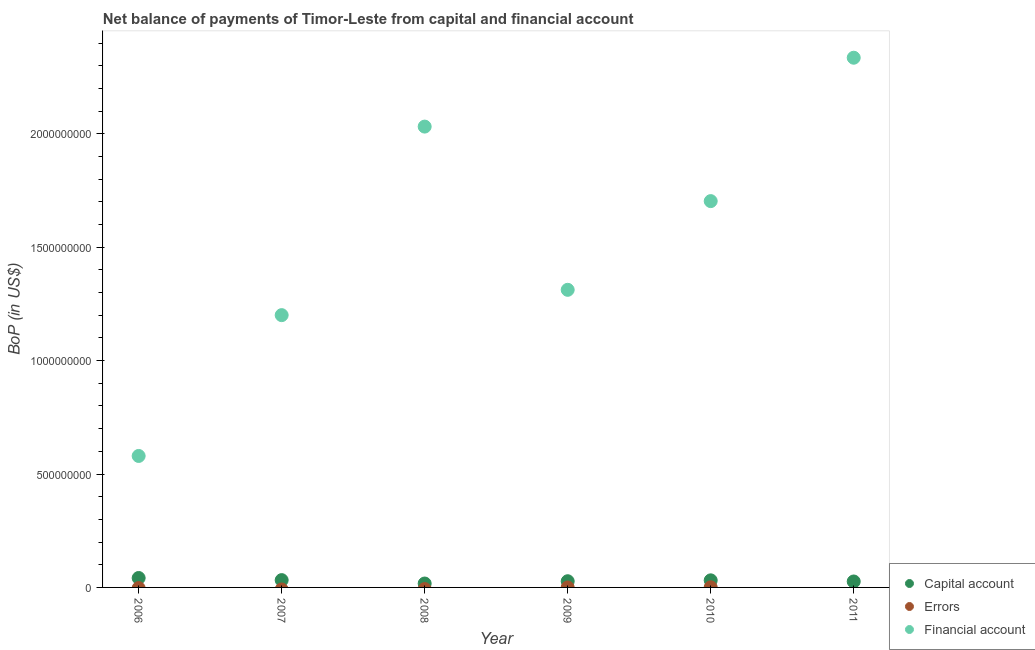How many different coloured dotlines are there?
Offer a terse response. 3. Is the number of dotlines equal to the number of legend labels?
Your answer should be compact. No. What is the amount of financial account in 2011?
Provide a short and direct response. 2.34e+09. Across all years, what is the maximum amount of financial account?
Make the answer very short. 2.34e+09. Across all years, what is the minimum amount of net capital account?
Your answer should be compact. 1.72e+07. What is the total amount of financial account in the graph?
Your answer should be very brief. 9.16e+09. What is the difference between the amount of net capital account in 2007 and that in 2009?
Keep it short and to the point. 4.88e+06. What is the difference between the amount of errors in 2009 and the amount of financial account in 2008?
Make the answer very short. -2.03e+09. What is the average amount of financial account per year?
Make the answer very short. 1.53e+09. In the year 2010, what is the difference between the amount of errors and amount of financial account?
Provide a short and direct response. -1.70e+09. What is the ratio of the amount of financial account in 2008 to that in 2009?
Provide a succinct answer. 1.55. Is the amount of financial account in 2007 less than that in 2008?
Offer a very short reply. Yes. Is the difference between the amount of net capital account in 2010 and 2011 greater than the difference between the amount of financial account in 2010 and 2011?
Keep it short and to the point. Yes. What is the difference between the highest and the second highest amount of net capital account?
Provide a short and direct response. 9.38e+06. What is the difference between the highest and the lowest amount of financial account?
Your answer should be very brief. 1.76e+09. In how many years, is the amount of net capital account greater than the average amount of net capital account taken over all years?
Make the answer very short. 3. Is the sum of the amount of financial account in 2007 and 2011 greater than the maximum amount of net capital account across all years?
Provide a succinct answer. Yes. Is the amount of net capital account strictly less than the amount of financial account over the years?
Offer a terse response. Yes. How many years are there in the graph?
Keep it short and to the point. 6. Does the graph contain any zero values?
Ensure brevity in your answer.  Yes. How many legend labels are there?
Your answer should be compact. 3. What is the title of the graph?
Provide a short and direct response. Net balance of payments of Timor-Leste from capital and financial account. What is the label or title of the X-axis?
Your response must be concise. Year. What is the label or title of the Y-axis?
Keep it short and to the point. BoP (in US$). What is the BoP (in US$) of Capital account in 2006?
Provide a succinct answer. 4.16e+07. What is the BoP (in US$) of Financial account in 2006?
Keep it short and to the point. 5.80e+08. What is the BoP (in US$) in Capital account in 2007?
Give a very brief answer. 3.22e+07. What is the BoP (in US$) in Errors in 2007?
Your answer should be compact. 0. What is the BoP (in US$) in Financial account in 2007?
Your answer should be very brief. 1.20e+09. What is the BoP (in US$) of Capital account in 2008?
Offer a very short reply. 1.72e+07. What is the BoP (in US$) of Financial account in 2008?
Give a very brief answer. 2.03e+09. What is the BoP (in US$) of Capital account in 2009?
Make the answer very short. 2.73e+07. What is the BoP (in US$) of Errors in 2009?
Your answer should be very brief. 0. What is the BoP (in US$) of Financial account in 2009?
Give a very brief answer. 1.31e+09. What is the BoP (in US$) of Capital account in 2010?
Make the answer very short. 3.13e+07. What is the BoP (in US$) of Errors in 2010?
Your answer should be compact. 5.13e+05. What is the BoP (in US$) in Financial account in 2010?
Make the answer very short. 1.70e+09. What is the BoP (in US$) of Capital account in 2011?
Give a very brief answer. 2.62e+07. What is the BoP (in US$) in Errors in 2011?
Make the answer very short. 0. What is the BoP (in US$) of Financial account in 2011?
Offer a very short reply. 2.34e+09. Across all years, what is the maximum BoP (in US$) of Capital account?
Provide a succinct answer. 4.16e+07. Across all years, what is the maximum BoP (in US$) of Errors?
Ensure brevity in your answer.  5.13e+05. Across all years, what is the maximum BoP (in US$) of Financial account?
Provide a succinct answer. 2.34e+09. Across all years, what is the minimum BoP (in US$) in Capital account?
Your answer should be very brief. 1.72e+07. Across all years, what is the minimum BoP (in US$) in Errors?
Provide a short and direct response. 0. Across all years, what is the minimum BoP (in US$) of Financial account?
Your response must be concise. 5.80e+08. What is the total BoP (in US$) of Capital account in the graph?
Your answer should be compact. 1.76e+08. What is the total BoP (in US$) of Errors in the graph?
Your answer should be compact. 5.13e+05. What is the total BoP (in US$) of Financial account in the graph?
Provide a short and direct response. 9.16e+09. What is the difference between the BoP (in US$) of Capital account in 2006 and that in 2007?
Your answer should be very brief. 9.38e+06. What is the difference between the BoP (in US$) in Financial account in 2006 and that in 2007?
Your answer should be compact. -6.21e+08. What is the difference between the BoP (in US$) in Capital account in 2006 and that in 2008?
Make the answer very short. 2.44e+07. What is the difference between the BoP (in US$) of Financial account in 2006 and that in 2008?
Offer a very short reply. -1.45e+09. What is the difference between the BoP (in US$) in Capital account in 2006 and that in 2009?
Offer a terse response. 1.43e+07. What is the difference between the BoP (in US$) in Financial account in 2006 and that in 2009?
Make the answer very short. -7.33e+08. What is the difference between the BoP (in US$) of Capital account in 2006 and that in 2010?
Give a very brief answer. 1.03e+07. What is the difference between the BoP (in US$) of Financial account in 2006 and that in 2010?
Keep it short and to the point. -1.12e+09. What is the difference between the BoP (in US$) in Capital account in 2006 and that in 2011?
Offer a terse response. 1.54e+07. What is the difference between the BoP (in US$) of Financial account in 2006 and that in 2011?
Your answer should be very brief. -1.76e+09. What is the difference between the BoP (in US$) in Capital account in 2007 and that in 2008?
Your answer should be compact. 1.50e+07. What is the difference between the BoP (in US$) of Financial account in 2007 and that in 2008?
Make the answer very short. -8.31e+08. What is the difference between the BoP (in US$) of Capital account in 2007 and that in 2009?
Ensure brevity in your answer.  4.88e+06. What is the difference between the BoP (in US$) in Financial account in 2007 and that in 2009?
Your answer should be compact. -1.12e+08. What is the difference between the BoP (in US$) of Capital account in 2007 and that in 2010?
Make the answer very short. 9.62e+05. What is the difference between the BoP (in US$) in Financial account in 2007 and that in 2010?
Provide a succinct answer. -5.03e+08. What is the difference between the BoP (in US$) of Capital account in 2007 and that in 2011?
Offer a very short reply. 5.99e+06. What is the difference between the BoP (in US$) in Financial account in 2007 and that in 2011?
Provide a succinct answer. -1.13e+09. What is the difference between the BoP (in US$) of Capital account in 2008 and that in 2009?
Keep it short and to the point. -1.01e+07. What is the difference between the BoP (in US$) in Financial account in 2008 and that in 2009?
Make the answer very short. 7.20e+08. What is the difference between the BoP (in US$) in Capital account in 2008 and that in 2010?
Your answer should be compact. -1.40e+07. What is the difference between the BoP (in US$) in Financial account in 2008 and that in 2010?
Make the answer very short. 3.29e+08. What is the difference between the BoP (in US$) of Capital account in 2008 and that in 2011?
Ensure brevity in your answer.  -8.99e+06. What is the difference between the BoP (in US$) in Financial account in 2008 and that in 2011?
Provide a succinct answer. -3.04e+08. What is the difference between the BoP (in US$) of Capital account in 2009 and that in 2010?
Make the answer very short. -3.92e+06. What is the difference between the BoP (in US$) of Financial account in 2009 and that in 2010?
Your answer should be compact. -3.91e+08. What is the difference between the BoP (in US$) in Capital account in 2009 and that in 2011?
Make the answer very short. 1.11e+06. What is the difference between the BoP (in US$) in Financial account in 2009 and that in 2011?
Provide a short and direct response. -1.02e+09. What is the difference between the BoP (in US$) in Capital account in 2010 and that in 2011?
Your answer should be very brief. 5.03e+06. What is the difference between the BoP (in US$) of Financial account in 2010 and that in 2011?
Offer a terse response. -6.32e+08. What is the difference between the BoP (in US$) of Capital account in 2006 and the BoP (in US$) of Financial account in 2007?
Offer a terse response. -1.16e+09. What is the difference between the BoP (in US$) of Capital account in 2006 and the BoP (in US$) of Financial account in 2008?
Ensure brevity in your answer.  -1.99e+09. What is the difference between the BoP (in US$) in Capital account in 2006 and the BoP (in US$) in Financial account in 2009?
Make the answer very short. -1.27e+09. What is the difference between the BoP (in US$) in Capital account in 2006 and the BoP (in US$) in Errors in 2010?
Make the answer very short. 4.11e+07. What is the difference between the BoP (in US$) in Capital account in 2006 and the BoP (in US$) in Financial account in 2010?
Offer a very short reply. -1.66e+09. What is the difference between the BoP (in US$) in Capital account in 2006 and the BoP (in US$) in Financial account in 2011?
Make the answer very short. -2.29e+09. What is the difference between the BoP (in US$) in Capital account in 2007 and the BoP (in US$) in Financial account in 2008?
Offer a very short reply. -2.00e+09. What is the difference between the BoP (in US$) of Capital account in 2007 and the BoP (in US$) of Financial account in 2009?
Offer a very short reply. -1.28e+09. What is the difference between the BoP (in US$) of Capital account in 2007 and the BoP (in US$) of Errors in 2010?
Give a very brief answer. 3.17e+07. What is the difference between the BoP (in US$) of Capital account in 2007 and the BoP (in US$) of Financial account in 2010?
Provide a short and direct response. -1.67e+09. What is the difference between the BoP (in US$) of Capital account in 2007 and the BoP (in US$) of Financial account in 2011?
Ensure brevity in your answer.  -2.30e+09. What is the difference between the BoP (in US$) of Capital account in 2008 and the BoP (in US$) of Financial account in 2009?
Give a very brief answer. -1.29e+09. What is the difference between the BoP (in US$) of Capital account in 2008 and the BoP (in US$) of Errors in 2010?
Your answer should be compact. 1.67e+07. What is the difference between the BoP (in US$) in Capital account in 2008 and the BoP (in US$) in Financial account in 2010?
Your answer should be very brief. -1.69e+09. What is the difference between the BoP (in US$) of Capital account in 2008 and the BoP (in US$) of Financial account in 2011?
Make the answer very short. -2.32e+09. What is the difference between the BoP (in US$) in Capital account in 2009 and the BoP (in US$) in Errors in 2010?
Provide a short and direct response. 2.68e+07. What is the difference between the BoP (in US$) of Capital account in 2009 and the BoP (in US$) of Financial account in 2010?
Offer a very short reply. -1.68e+09. What is the difference between the BoP (in US$) of Capital account in 2009 and the BoP (in US$) of Financial account in 2011?
Your response must be concise. -2.31e+09. What is the difference between the BoP (in US$) of Capital account in 2010 and the BoP (in US$) of Financial account in 2011?
Provide a short and direct response. -2.30e+09. What is the difference between the BoP (in US$) of Errors in 2010 and the BoP (in US$) of Financial account in 2011?
Your answer should be compact. -2.33e+09. What is the average BoP (in US$) in Capital account per year?
Offer a very short reply. 2.93e+07. What is the average BoP (in US$) in Errors per year?
Your answer should be very brief. 8.55e+04. What is the average BoP (in US$) of Financial account per year?
Keep it short and to the point. 1.53e+09. In the year 2006, what is the difference between the BoP (in US$) in Capital account and BoP (in US$) in Financial account?
Ensure brevity in your answer.  -5.38e+08. In the year 2007, what is the difference between the BoP (in US$) of Capital account and BoP (in US$) of Financial account?
Make the answer very short. -1.17e+09. In the year 2008, what is the difference between the BoP (in US$) of Capital account and BoP (in US$) of Financial account?
Your answer should be very brief. -2.01e+09. In the year 2009, what is the difference between the BoP (in US$) of Capital account and BoP (in US$) of Financial account?
Provide a short and direct response. -1.28e+09. In the year 2010, what is the difference between the BoP (in US$) of Capital account and BoP (in US$) of Errors?
Your answer should be very brief. 3.07e+07. In the year 2010, what is the difference between the BoP (in US$) in Capital account and BoP (in US$) in Financial account?
Your response must be concise. -1.67e+09. In the year 2010, what is the difference between the BoP (in US$) in Errors and BoP (in US$) in Financial account?
Your answer should be very brief. -1.70e+09. In the year 2011, what is the difference between the BoP (in US$) of Capital account and BoP (in US$) of Financial account?
Your answer should be very brief. -2.31e+09. What is the ratio of the BoP (in US$) of Capital account in 2006 to that in 2007?
Provide a succinct answer. 1.29. What is the ratio of the BoP (in US$) in Financial account in 2006 to that in 2007?
Make the answer very short. 0.48. What is the ratio of the BoP (in US$) of Capital account in 2006 to that in 2008?
Give a very brief answer. 2.41. What is the ratio of the BoP (in US$) in Financial account in 2006 to that in 2008?
Offer a very short reply. 0.29. What is the ratio of the BoP (in US$) in Capital account in 2006 to that in 2009?
Offer a very short reply. 1.52. What is the ratio of the BoP (in US$) in Financial account in 2006 to that in 2009?
Offer a very short reply. 0.44. What is the ratio of the BoP (in US$) of Capital account in 2006 to that in 2010?
Offer a very short reply. 1.33. What is the ratio of the BoP (in US$) of Financial account in 2006 to that in 2010?
Your answer should be very brief. 0.34. What is the ratio of the BoP (in US$) of Capital account in 2006 to that in 2011?
Keep it short and to the point. 1.59. What is the ratio of the BoP (in US$) in Financial account in 2006 to that in 2011?
Provide a short and direct response. 0.25. What is the ratio of the BoP (in US$) of Capital account in 2007 to that in 2008?
Keep it short and to the point. 1.87. What is the ratio of the BoP (in US$) of Financial account in 2007 to that in 2008?
Make the answer very short. 0.59. What is the ratio of the BoP (in US$) of Capital account in 2007 to that in 2009?
Ensure brevity in your answer.  1.18. What is the ratio of the BoP (in US$) in Financial account in 2007 to that in 2009?
Your answer should be compact. 0.91. What is the ratio of the BoP (in US$) in Capital account in 2007 to that in 2010?
Offer a terse response. 1.03. What is the ratio of the BoP (in US$) in Financial account in 2007 to that in 2010?
Make the answer very short. 0.7. What is the ratio of the BoP (in US$) of Capital account in 2007 to that in 2011?
Offer a terse response. 1.23. What is the ratio of the BoP (in US$) in Financial account in 2007 to that in 2011?
Your answer should be compact. 0.51. What is the ratio of the BoP (in US$) in Capital account in 2008 to that in 2009?
Provide a succinct answer. 0.63. What is the ratio of the BoP (in US$) in Financial account in 2008 to that in 2009?
Provide a short and direct response. 1.55. What is the ratio of the BoP (in US$) in Capital account in 2008 to that in 2010?
Your answer should be very brief. 0.55. What is the ratio of the BoP (in US$) in Financial account in 2008 to that in 2010?
Provide a short and direct response. 1.19. What is the ratio of the BoP (in US$) in Capital account in 2008 to that in 2011?
Provide a short and direct response. 0.66. What is the ratio of the BoP (in US$) in Financial account in 2008 to that in 2011?
Your answer should be very brief. 0.87. What is the ratio of the BoP (in US$) in Capital account in 2009 to that in 2010?
Keep it short and to the point. 0.87. What is the ratio of the BoP (in US$) in Financial account in 2009 to that in 2010?
Offer a very short reply. 0.77. What is the ratio of the BoP (in US$) in Capital account in 2009 to that in 2011?
Your response must be concise. 1.04. What is the ratio of the BoP (in US$) of Financial account in 2009 to that in 2011?
Provide a succinct answer. 0.56. What is the ratio of the BoP (in US$) in Capital account in 2010 to that in 2011?
Your answer should be compact. 1.19. What is the ratio of the BoP (in US$) in Financial account in 2010 to that in 2011?
Provide a succinct answer. 0.73. What is the difference between the highest and the second highest BoP (in US$) in Capital account?
Offer a terse response. 9.38e+06. What is the difference between the highest and the second highest BoP (in US$) of Financial account?
Offer a very short reply. 3.04e+08. What is the difference between the highest and the lowest BoP (in US$) of Capital account?
Make the answer very short. 2.44e+07. What is the difference between the highest and the lowest BoP (in US$) in Errors?
Give a very brief answer. 5.13e+05. What is the difference between the highest and the lowest BoP (in US$) of Financial account?
Offer a very short reply. 1.76e+09. 